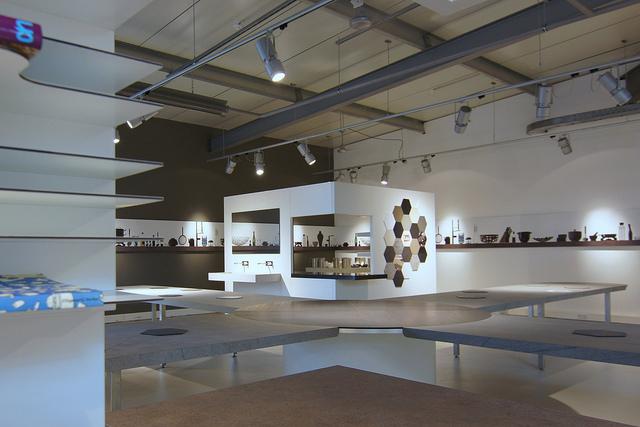What room is this?
Quick response, please. Dining. What color is the wall?
Be succinct. White. How many shots in this scene?
Give a very brief answer. 1. How many lights are in this room?
Answer briefly. 12. 